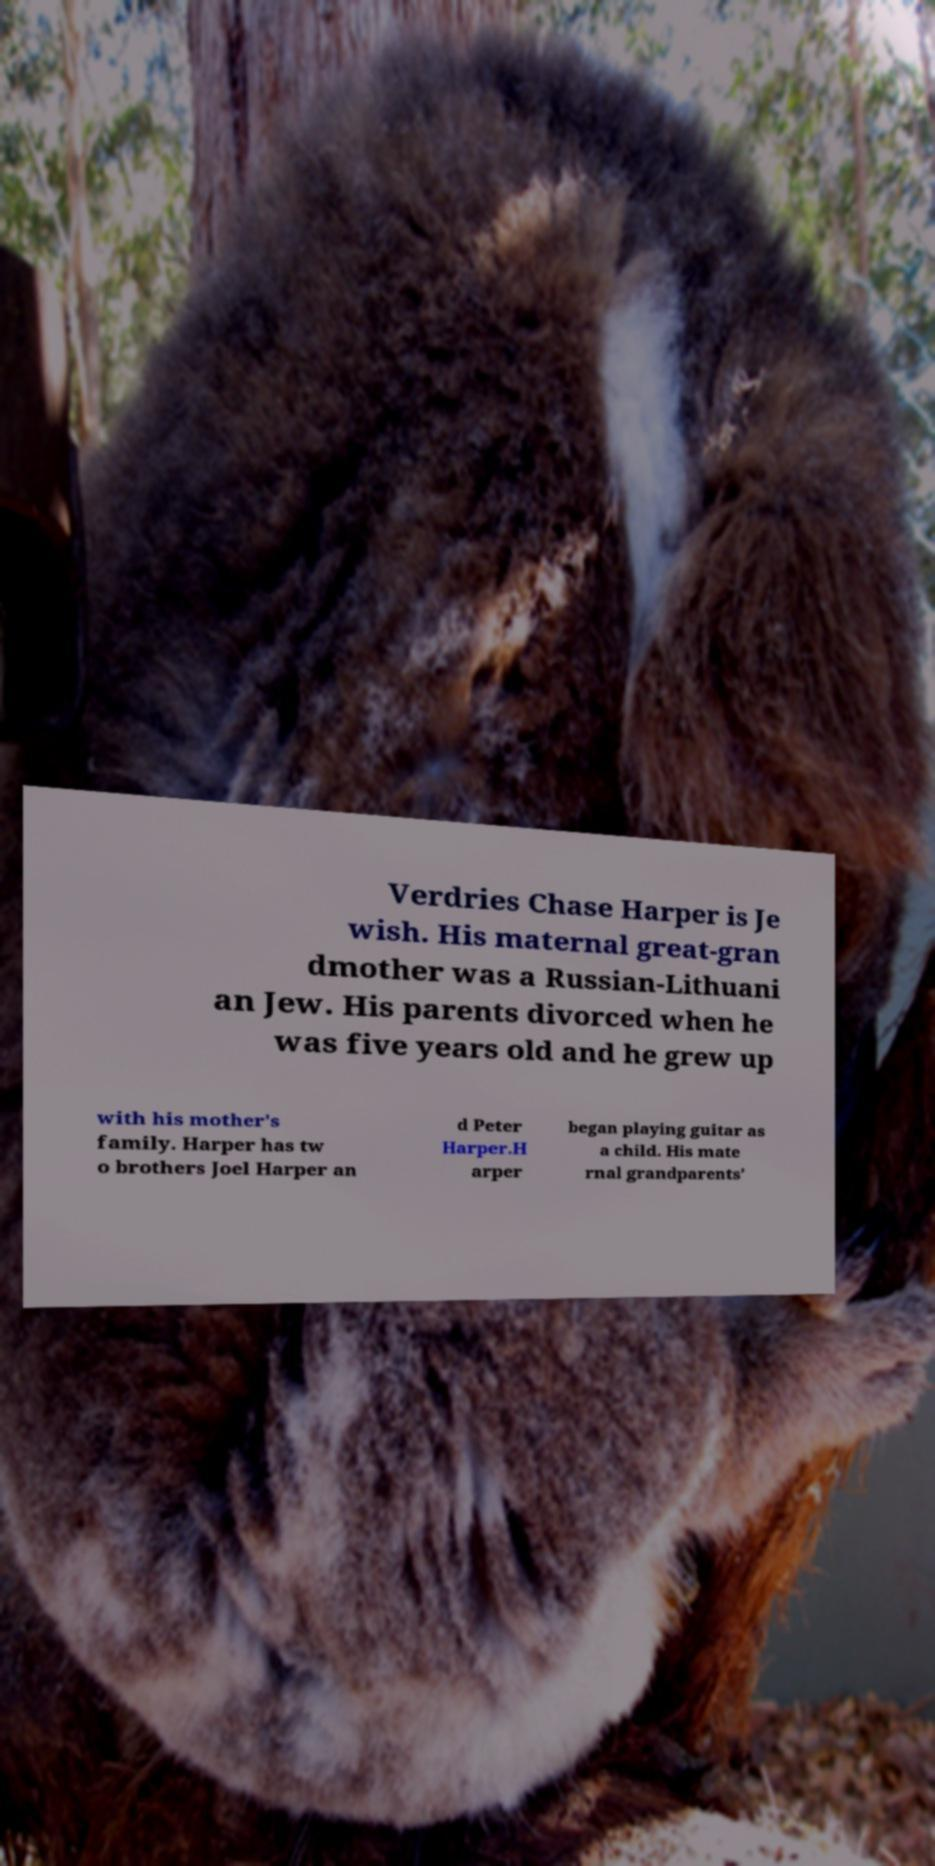What messages or text are displayed in this image? I need them in a readable, typed format. Verdries Chase Harper is Je wish. His maternal great-gran dmother was a Russian-Lithuani an Jew. His parents divorced when he was five years old and he grew up with his mother's family. Harper has tw o brothers Joel Harper an d Peter Harper.H arper began playing guitar as a child. His mate rnal grandparents' 